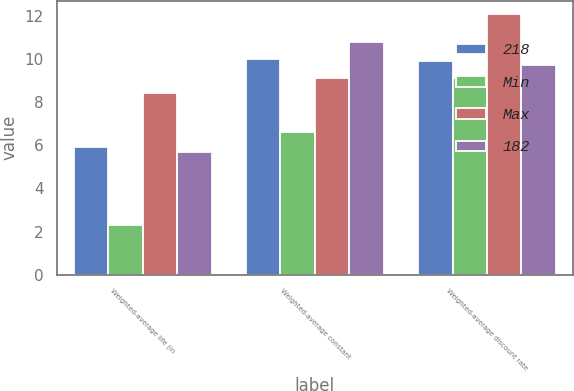<chart> <loc_0><loc_0><loc_500><loc_500><stacked_bar_chart><ecel><fcel>Weighted-average life (in<fcel>Weighted-average constant<fcel>Weighted-average discount rate<nl><fcel>218<fcel>5.9<fcel>10<fcel>9.9<nl><fcel>Min<fcel>2.3<fcel>6.6<fcel>9.1<nl><fcel>Max<fcel>8.4<fcel>9.1<fcel>12.1<nl><fcel>182<fcel>5.7<fcel>10.8<fcel>9.7<nl></chart> 